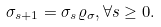Convert formula to latex. <formula><loc_0><loc_0><loc_500><loc_500>\sigma _ { s + 1 } = \sigma _ { s } \varrho _ { \sigma } , \forall s \geq 0 .</formula> 